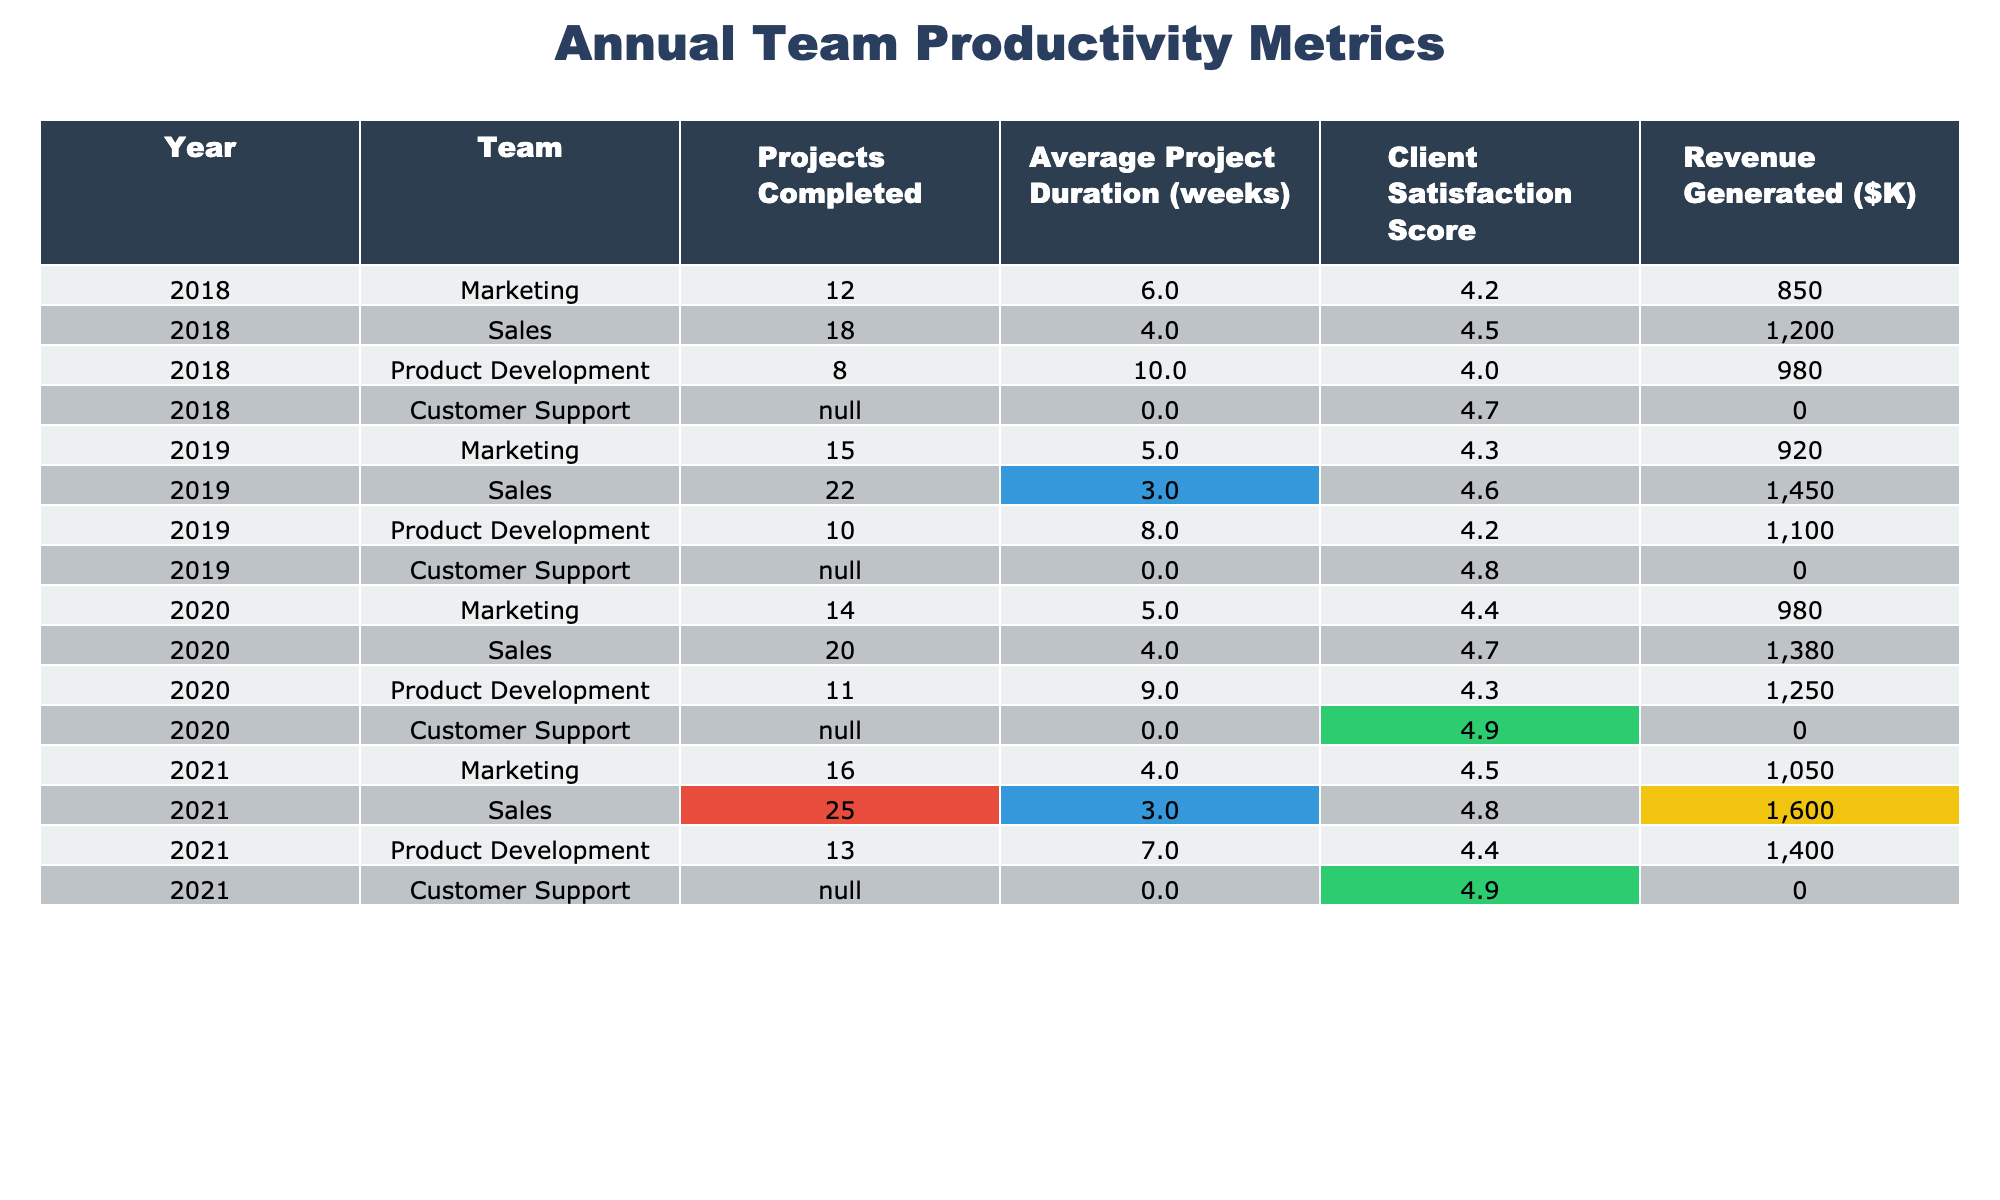What was the Client Satisfaction Score for Sales in 2021? The table shows the data for Sales in 2021, which displays a Client Satisfaction Score of 4.8.
Answer: 4.8 What team completed the most projects in 2020? Looking at the Projects Completed column for 2020, the team with the highest number of completed projects is Sales, with 20 projects.
Answer: Sales What is the average project duration for Marketing in 2019? The table indicates an Average Project Duration of 5 weeks for Marketing in 2019.
Answer: 5 weeks Which team had the highest revenue generated in 2019? By reviewing the Revenue Generated column for 2019, Sales generated the highest revenue at $1450K.
Answer: Sales What is the total revenue generated by Product Development over the years provided? The revenue generated by Product Development each year is $980K (2018) + $1100K (2019) + $1250K (2020) + $1400K (2021) = $3730K.
Answer: $3730K Was the Client Satisfaction Score for Customer Support consistent across the years? The Client Satisfaction Scores for Customer Support are not provided for the years; thus, it's not possible to consider them consistent.
Answer: No which team showed the highest Client Satisfaction Score in 2020? The scores indicate that Customer Support had the highest Client Satisfaction Score of 4.9 in 2020.
Answer: Customer Support What was the average Client Satisfaction Score for all teams across the years? Summing the Client Satisfaction Scores (4.2, 4.5, 4.0, 4.7, 4.3, 4.6, 4.2, 4.8, 4.4, 4.7, 4.3, 4.9, 4.5, 4.8, 4.4, 4.9) and dividing by 16 gives an average of 4.5.
Answer: 4.5 Which year experienced the least Average Project Duration for Sales? The Average Project Duration for Sales in 2018, 2019, 2020, and 2021 is 4 weeks in each year, indicating the least duration occurred in all these years.
Answer: 2018, 2019, 2020, 2021 If you consider the years provided, which team showed the largest improvement in Client Satisfaction Score from 2018 to 2021? The Client Satisfaction Scores for Marketing increased from 4.2 in 2018 to 4.5 in 2021, a difference of 0.3. By comparing each team, the largest improvement is made by Marketing.
Answer: Marketing 